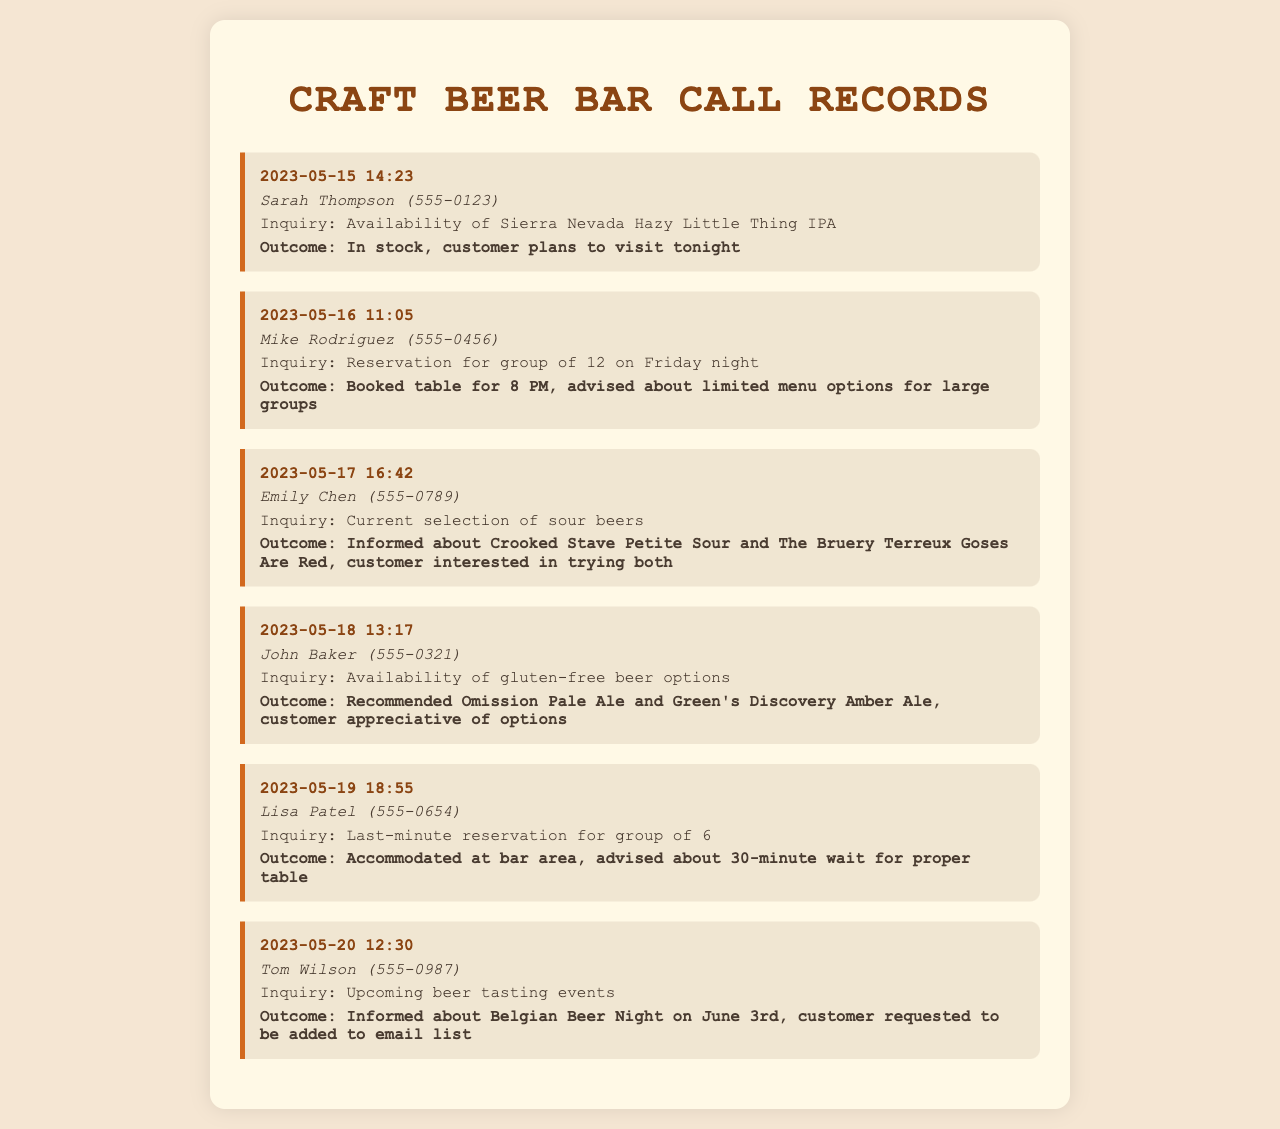What was the date of the first call? The first recorded call was made on May 15, 2023.
Answer: May 15, 2023 Who inquired about gluten-free beer options? The caller John Baker asked about gluten-free beer options.
Answer: John Baker How many people was the reservation for on Friday night? Mike Rodriguez requested a reservation for a group of 12 on Friday night.
Answer: 12 What beer was mentioned as available for Sarah Thompson? Sarah Thompson inquired about the Sierra Nevada Hazy Little Thing IPA.
Answer: Sierra Nevada Hazy Little Thing IPA What time was the reservation booked for Mike Rodriguez? Mike Rodriguez's reservation was booked for 8 PM.
Answer: 8 PM Which beer tasting event was mentioned? Tom Wilson was informed about the Belgian Beer Night on June 3rd.
Answer: Belgian Beer Night on June 3rd How many people were accommodated for Lisa Patel’s last-minute reservation? Lisa Patel's last-minute reservation was for a group of 6.
Answer: 6 What did Emily Chen express interest in trying? Emily Chen showed interest in trying the Crooked Stave Petite Sour and The Bruery Terreux Goses Are Red.
Answer: Both How did John Baker feel about the gluten-free options? John Baker was appreciative of the gluten-free beer options recommended to him.
Answer: Appreciative 